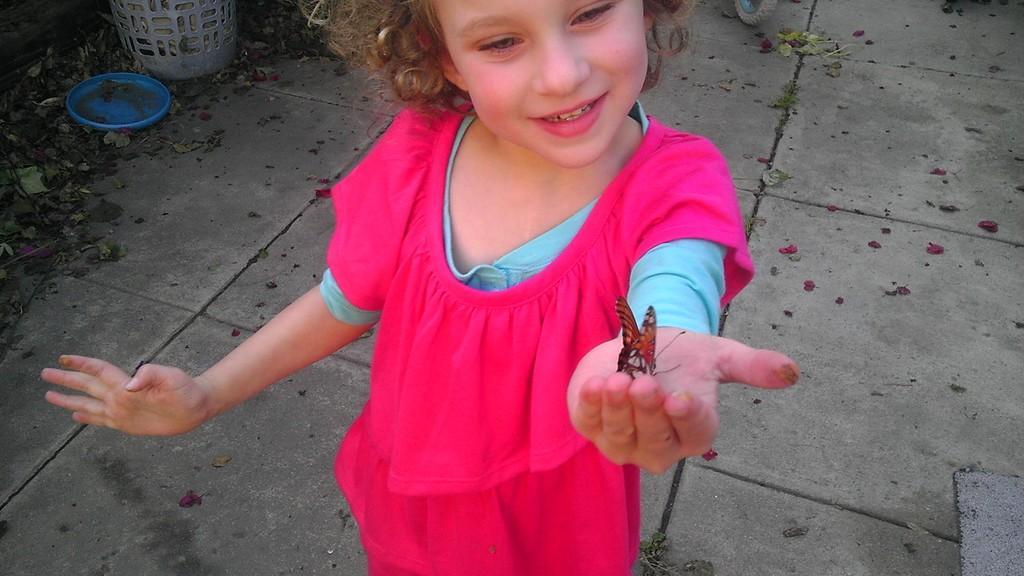Describe this image in one or two sentences. In this image we can see a child and a butterfly in a hand and there are few objects on the ground. 